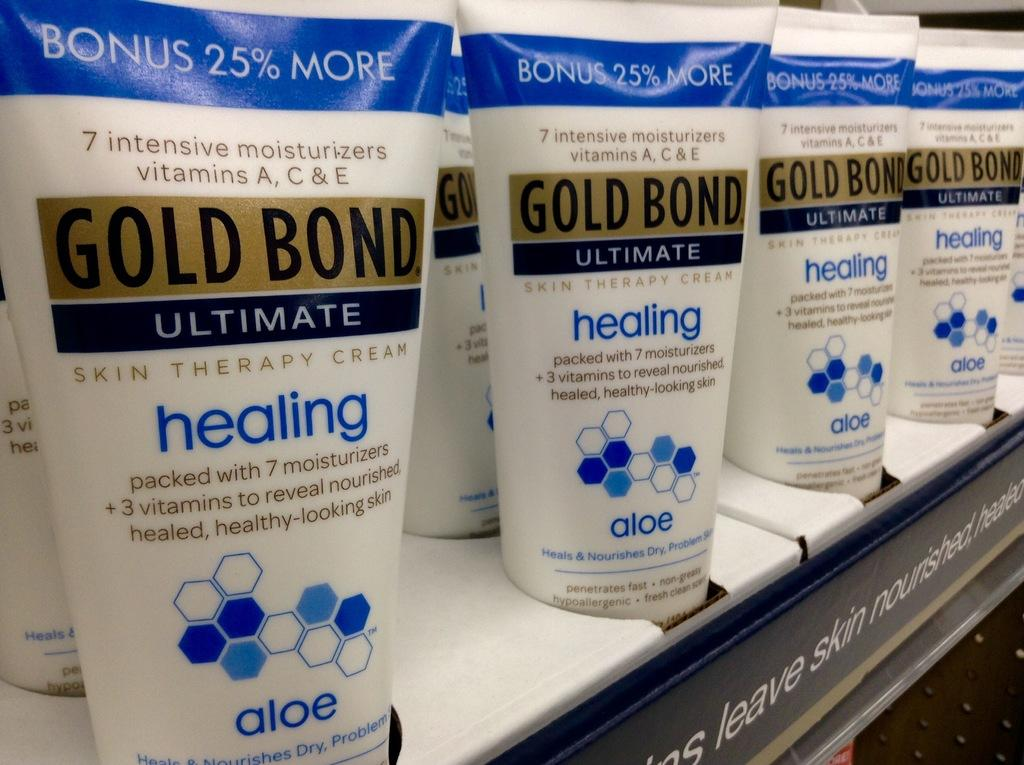<image>
Present a compact description of the photo's key features. A shelf that displays bottles of Gold Bond Ultimate healing 